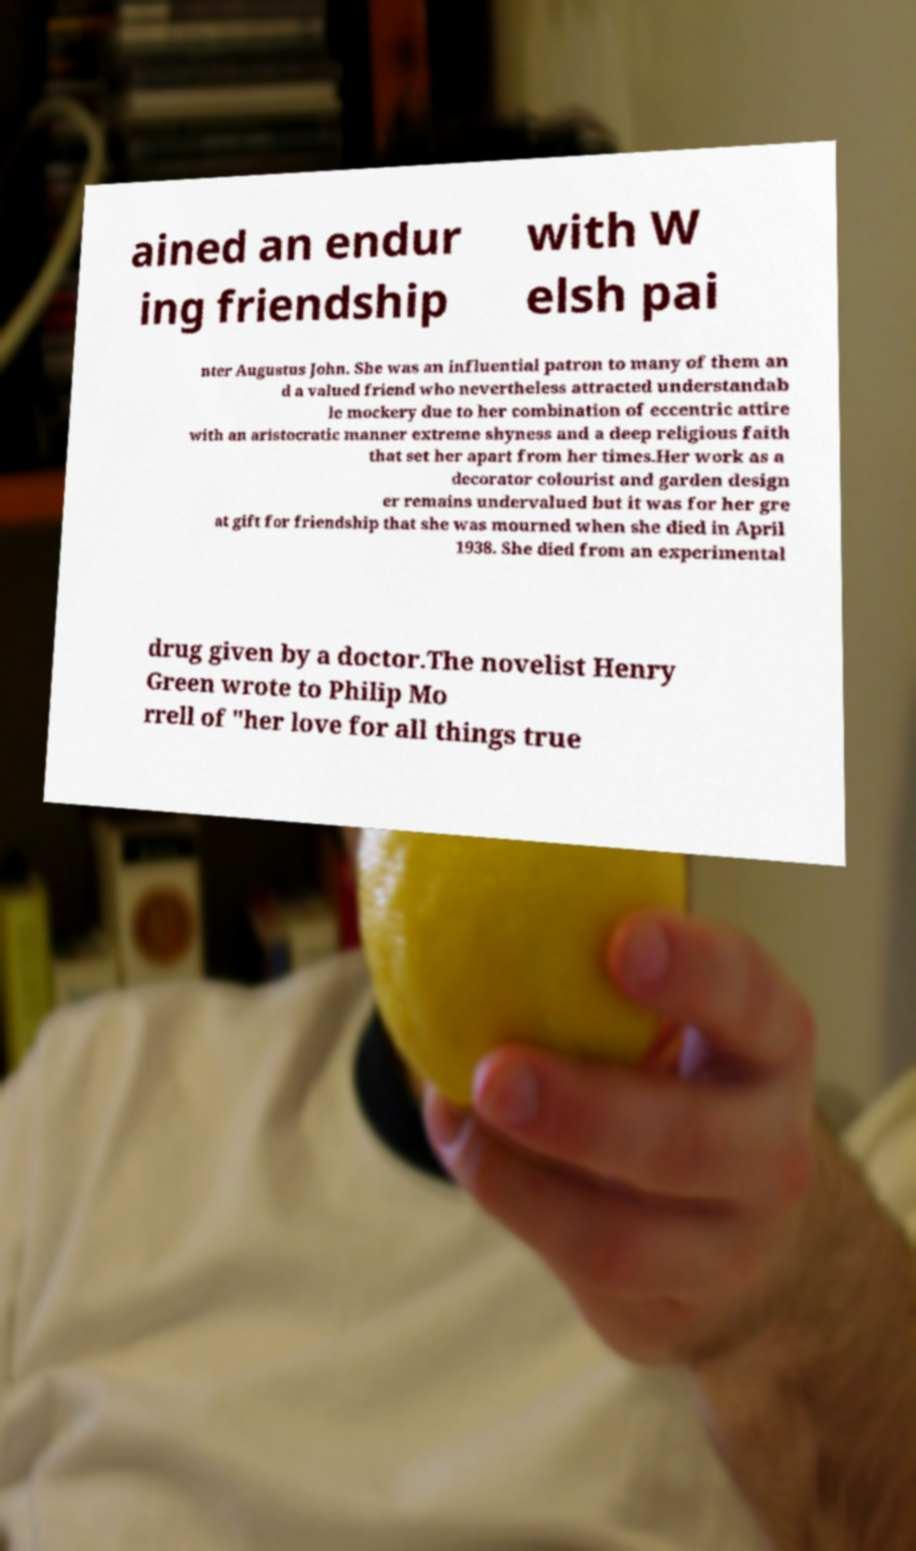What messages or text are displayed in this image? I need them in a readable, typed format. ained an endur ing friendship with W elsh pai nter Augustus John. She was an influential patron to many of them an d a valued friend who nevertheless attracted understandab le mockery due to her combination of eccentric attire with an aristocratic manner extreme shyness and a deep religious faith that set her apart from her times.Her work as a decorator colourist and garden design er remains undervalued but it was for her gre at gift for friendship that she was mourned when she died in April 1938. She died from an experimental drug given by a doctor.The novelist Henry Green wrote to Philip Mo rrell of "her love for all things true 